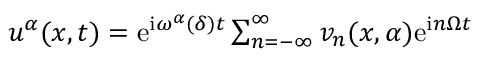<formula> <loc_0><loc_0><loc_500><loc_500>\begin{array} { r } { u ^ { \alpha } ( x , t ) = e ^ { i \omega ^ { \alpha } ( \delta ) t } \sum _ { n = - \infty } ^ { \infty } v _ { n } ( x , \alpha ) e ^ { i n \Omega t } } \end{array}</formula> 